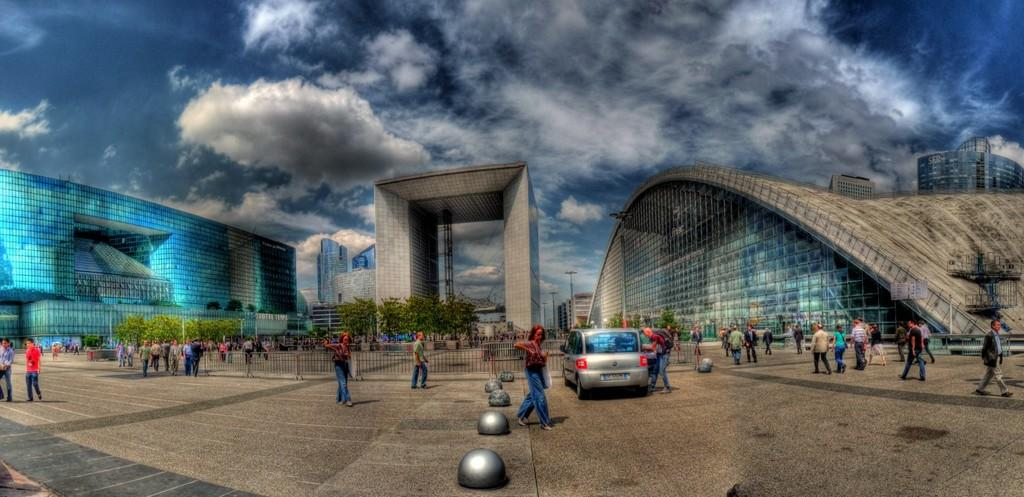How many people are in the image? There are people in the image, but the exact number is not specified. What type of vehicle is present in the image? There is a car in the image. What is separating the area in the image? There is a fence in the image. What can be seen in the distance in the image? There are trees and buildings in the background of the image. What is visible in the sky in the image? There are clouds in the sky. Where is the stove located in the image? There is no stove present in the image. What type of park can be seen in the image? There is no park present in the image. 